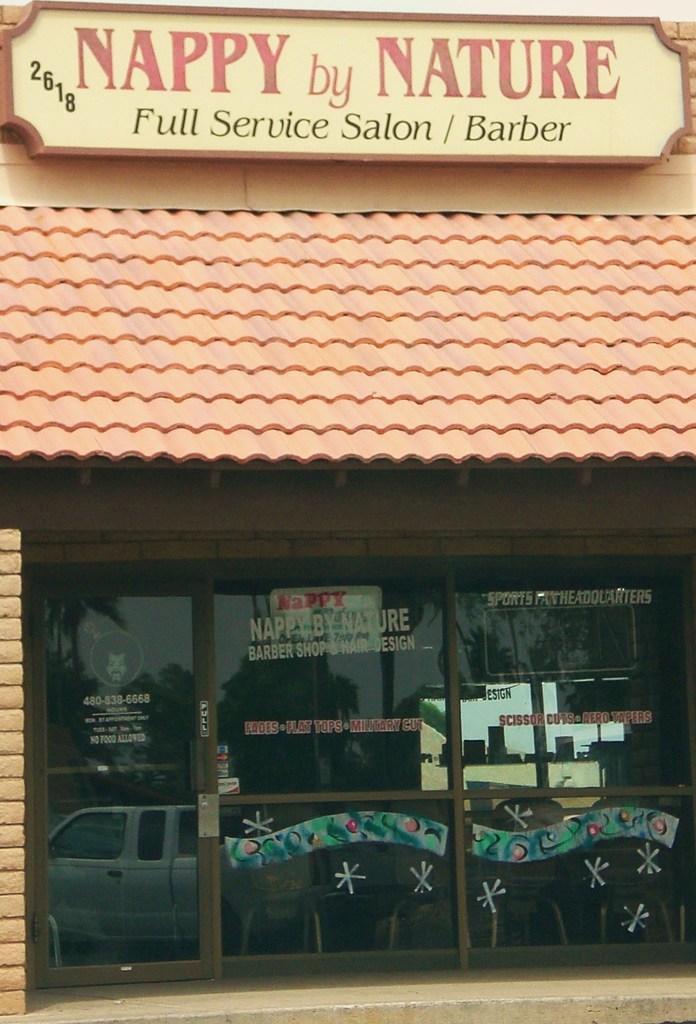Can you describe this image briefly? In this image a building , at the top of building there is a board , on board there is a text and there is a glass door , through door I can see a vehicle and trees. 